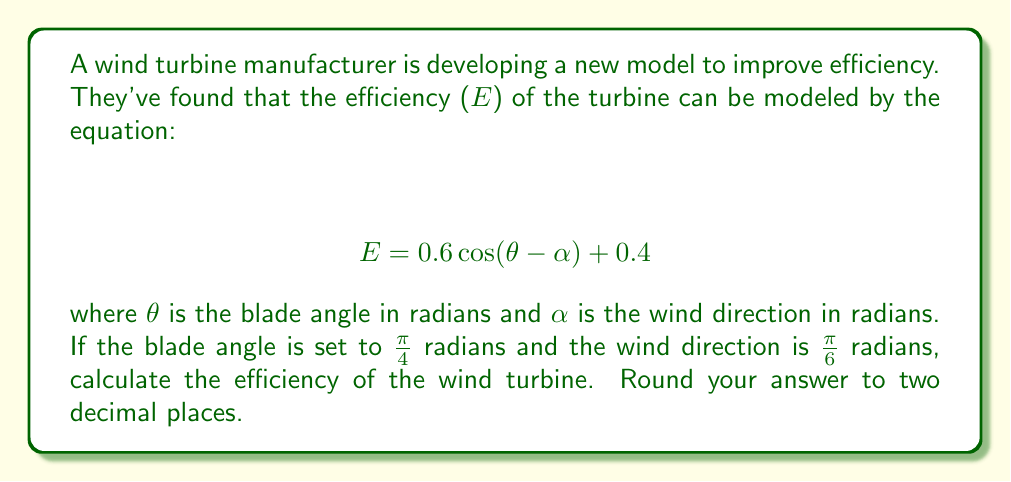Show me your answer to this math problem. To solve this problem, we'll follow these steps:

1) We're given the equation for efficiency:
   $$ E = 0.6 \cos(\theta - \alpha) + 0.4 $$

2) We're also given:
   $\theta = \frac{\pi}{4}$ radians (blade angle)
   $\alpha = \frac{\pi}{6}$ radians (wind direction)

3) Let's substitute these values into the equation:
   $$ E = 0.6 \cos(\frac{\pi}{4} - \frac{\pi}{6}) + 0.4 $$

4) Simplify inside the parentheses:
   $$ E = 0.6 \cos(\frac{\pi}{12}) + 0.4 $$

5) Now, we need to calculate $\cos(\frac{\pi}{12})$. This is not a common angle, so we'll use a calculator.
   $\cos(\frac{\pi}{12}) \approx 0.9659$

6) Substitute this value:
   $$ E = 0.6 (0.9659) + 0.4 $$

7) Multiply:
   $$ E = 0.57954 + 0.4 $$

8) Add:
   $$ E = 0.97954 $$

9) Rounding to two decimal places:
   $$ E \approx 0.98 $$

Therefore, the efficiency of the wind turbine is approximately 0.98 or 98%.
Answer: 0.98 